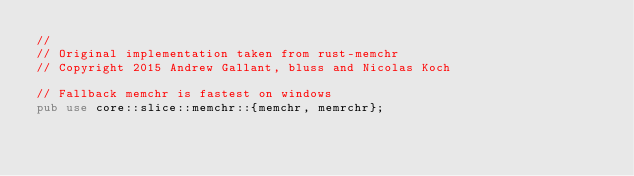Convert code to text. <code><loc_0><loc_0><loc_500><loc_500><_Rust_>//
// Original implementation taken from rust-memchr
// Copyright 2015 Andrew Gallant, bluss and Nicolas Koch

// Fallback memchr is fastest on windows
pub use core::slice::memchr::{memchr, memrchr};
</code> 